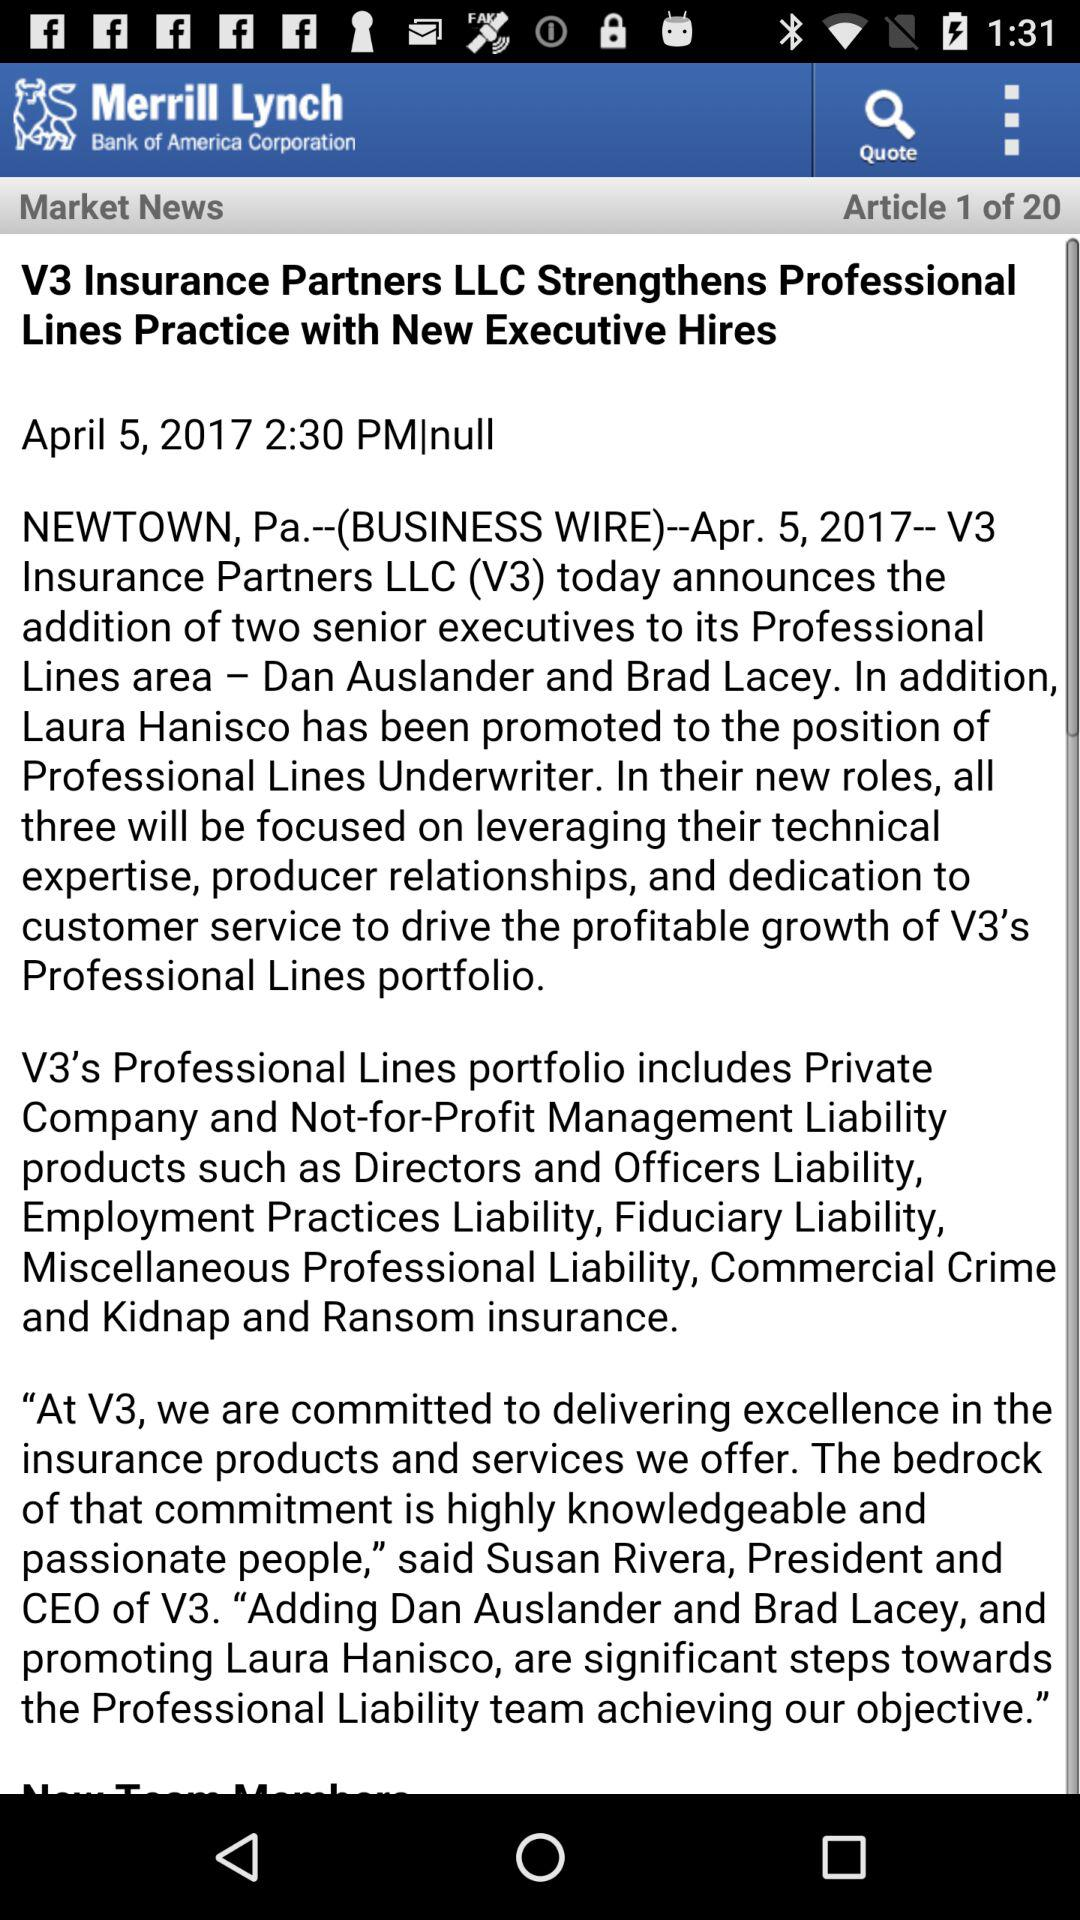What is the application name? The application name is "Merrill Lynch". 